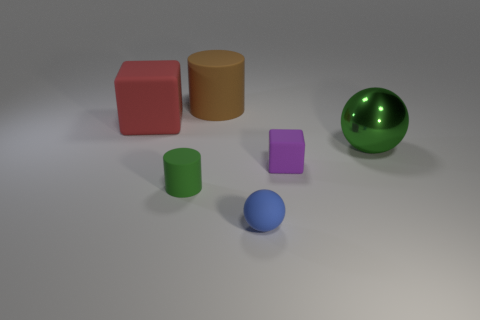Is the number of small purple cubes in front of the large rubber block the same as the number of large blocks?
Offer a terse response. Yes. There is a thing behind the block to the left of the tiny green rubber thing; what number of rubber cubes are in front of it?
Make the answer very short. 2. Are there any red cylinders of the same size as the brown cylinder?
Give a very brief answer. No. Is the number of small blue rubber things in front of the tiny sphere less than the number of big gray rubber blocks?
Provide a succinct answer. No. There is a cylinder in front of the matte cube that is to the left of the rubber block that is right of the blue rubber ball; what is its material?
Offer a very short reply. Rubber. Is the number of green things that are to the right of the small matte cube greater than the number of large red rubber cubes that are behind the big block?
Your response must be concise. Yes. How many rubber objects are either blocks or large red objects?
Your answer should be compact. 2. The other tiny thing that is the same color as the metallic object is what shape?
Your response must be concise. Cylinder. What is the thing that is right of the small cube made of?
Provide a succinct answer. Metal. What number of objects are either purple objects or matte objects that are to the left of the tiny blue object?
Your answer should be compact. 4. 